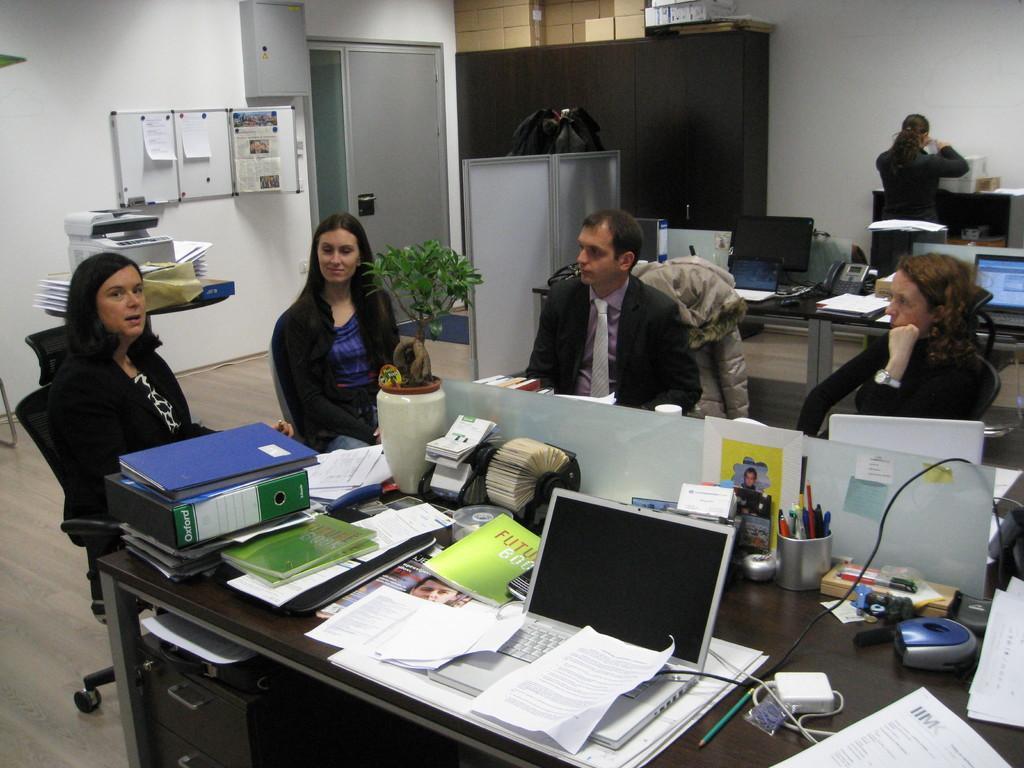Describe this image in one or two sentences. This image consists of five people sitting in a room. In the front, there is a table on which there are laptop, papers, files and pen stands. At the bottom, there is a floor. In the background, there are cupboards, plant and wall on which there are three boards fixed. 